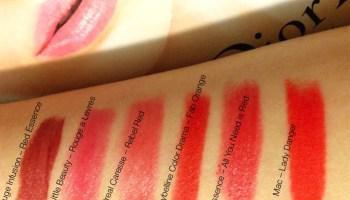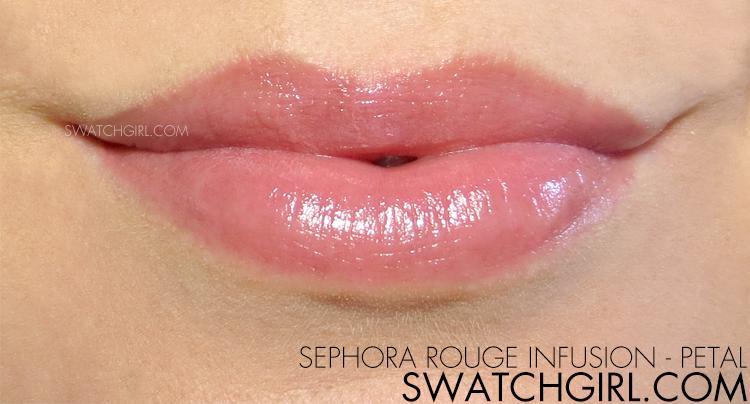The first image is the image on the left, the second image is the image on the right. For the images displayed, is the sentence "A pair of lips is visible in the right image" factually correct? Answer yes or no. Yes. The first image is the image on the left, the second image is the image on the right. Given the left and right images, does the statement "Right image shows one pair of tinted lips." hold true? Answer yes or no. Yes. 